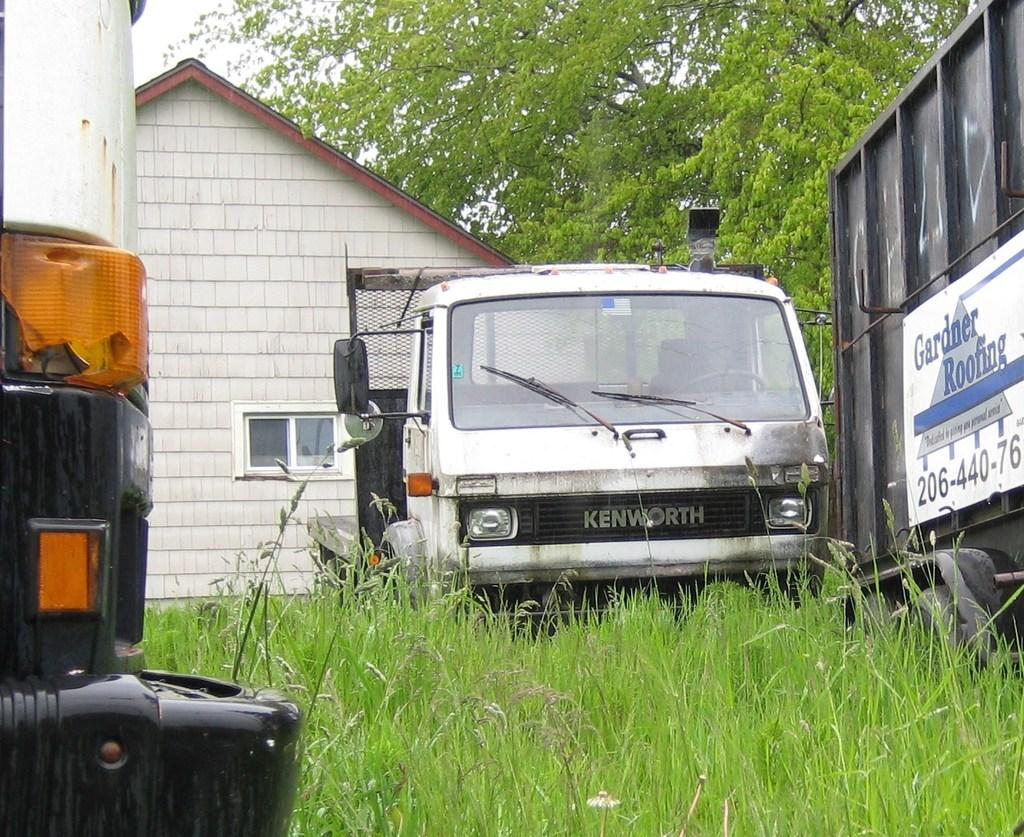<image>
Offer a succinct explanation of the picture presented. A white truck says Kenworth and is parked in the grass by a house. 